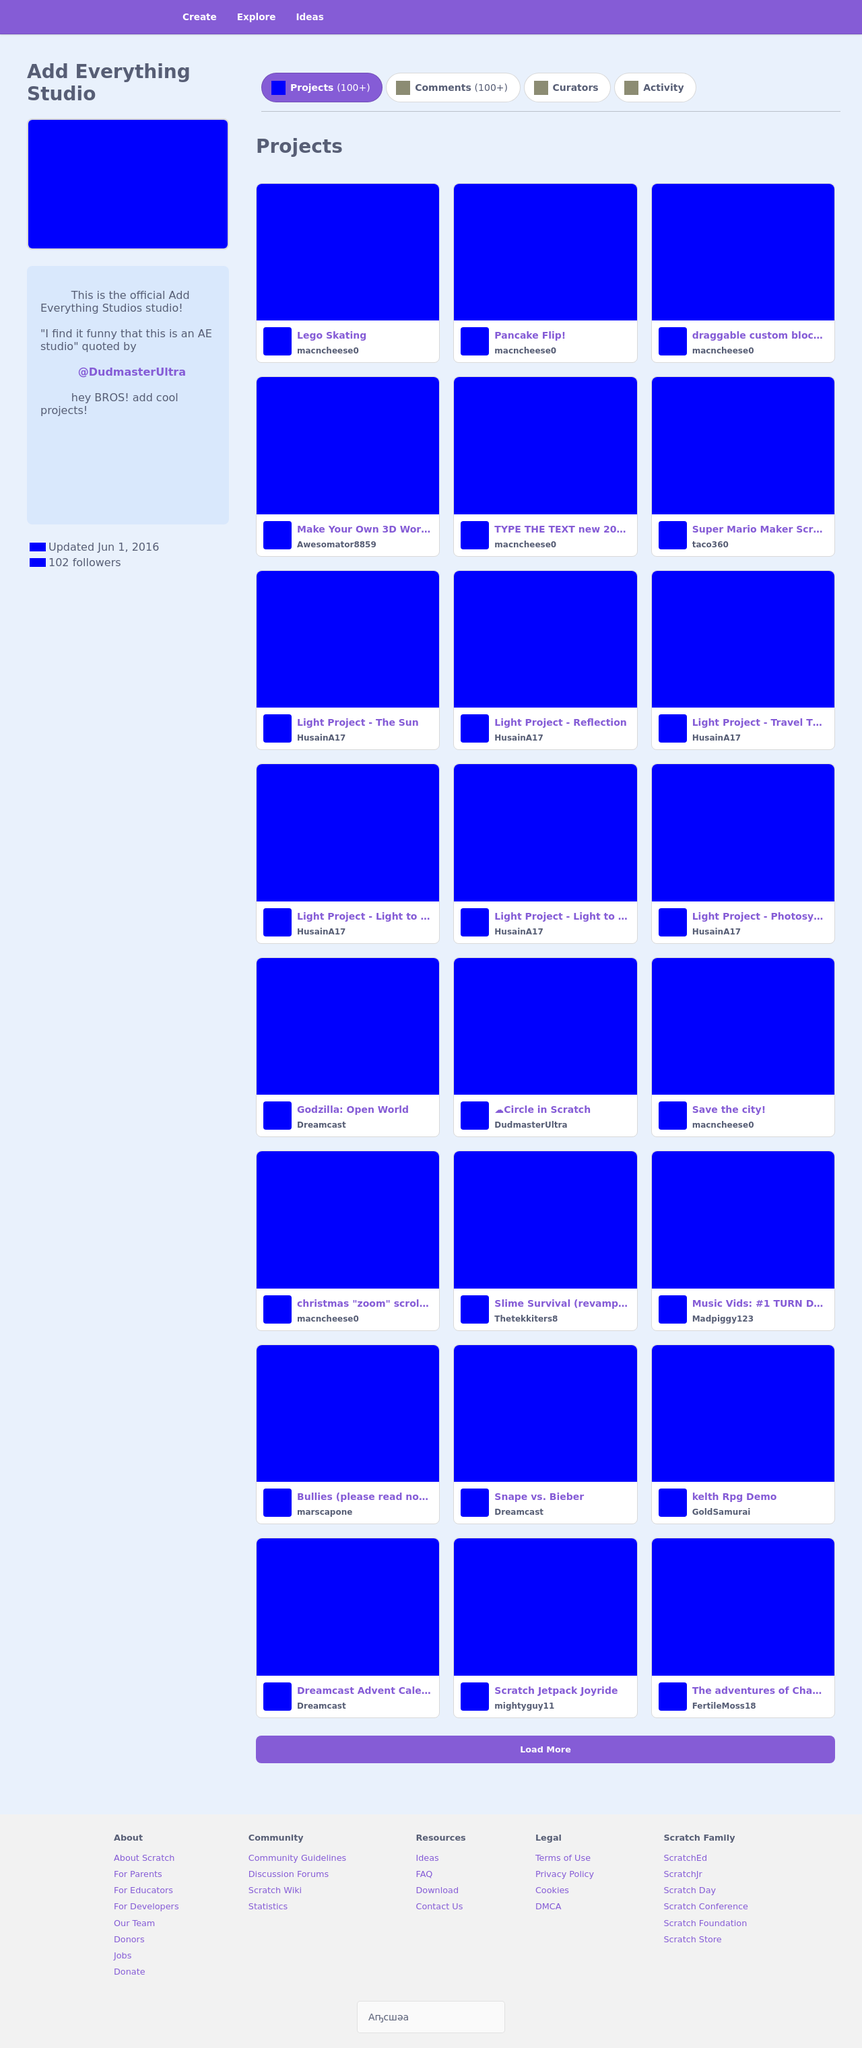How can I start building this website with HTML from the ground up? To create a website similar to the 'Add Everything Studio' using HTML, start by setting up a basic HTML structure. Include sections for navigation, a main content area for projects, and a footer. Use div tags to structure your layout, and then style it using CSS for the characteristic blue theme. For dynamic content like project thumbnails and descriptions, you might consider learning some JavaScript to pull data dynamically, perhaps from a database or via an API if your content is hosted elsewhere. Make sure to also include links and interactive elements to make the website engaging and functional. 